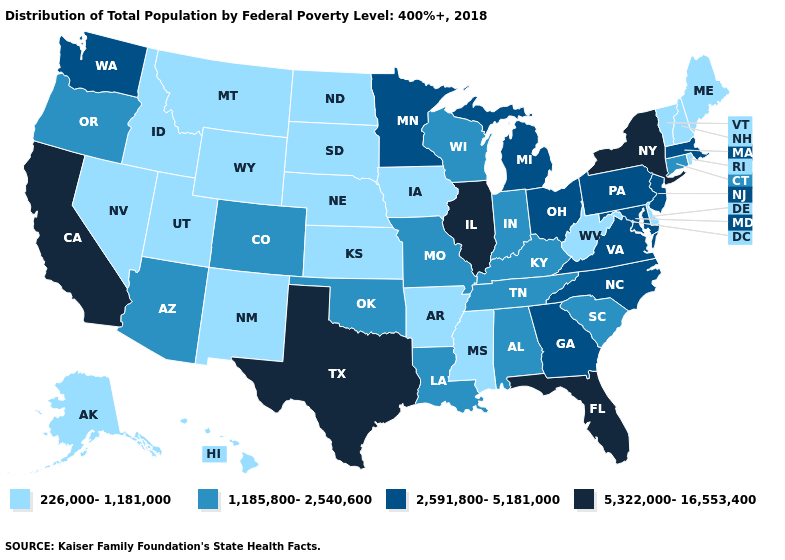What is the lowest value in the USA?
Short answer required. 226,000-1,181,000. Name the states that have a value in the range 2,591,800-5,181,000?
Concise answer only. Georgia, Maryland, Massachusetts, Michigan, Minnesota, New Jersey, North Carolina, Ohio, Pennsylvania, Virginia, Washington. What is the value of Missouri?
Be succinct. 1,185,800-2,540,600. Does Illinois have the highest value in the MidWest?
Concise answer only. Yes. How many symbols are there in the legend?
Answer briefly. 4. Does the map have missing data?
Answer briefly. No. Among the states that border Ohio , does Pennsylvania have the highest value?
Be succinct. Yes. Which states have the lowest value in the South?
Quick response, please. Arkansas, Delaware, Mississippi, West Virginia. What is the value of West Virginia?
Be succinct. 226,000-1,181,000. Name the states that have a value in the range 5,322,000-16,553,400?
Be succinct. California, Florida, Illinois, New York, Texas. What is the value of New Jersey?
Keep it brief. 2,591,800-5,181,000. What is the value of Louisiana?
Write a very short answer. 1,185,800-2,540,600. Which states hav the highest value in the MidWest?
Be succinct. Illinois. Among the states that border Maryland , does West Virginia have the highest value?
Quick response, please. No. Does Pennsylvania have the lowest value in the Northeast?
Concise answer only. No. 